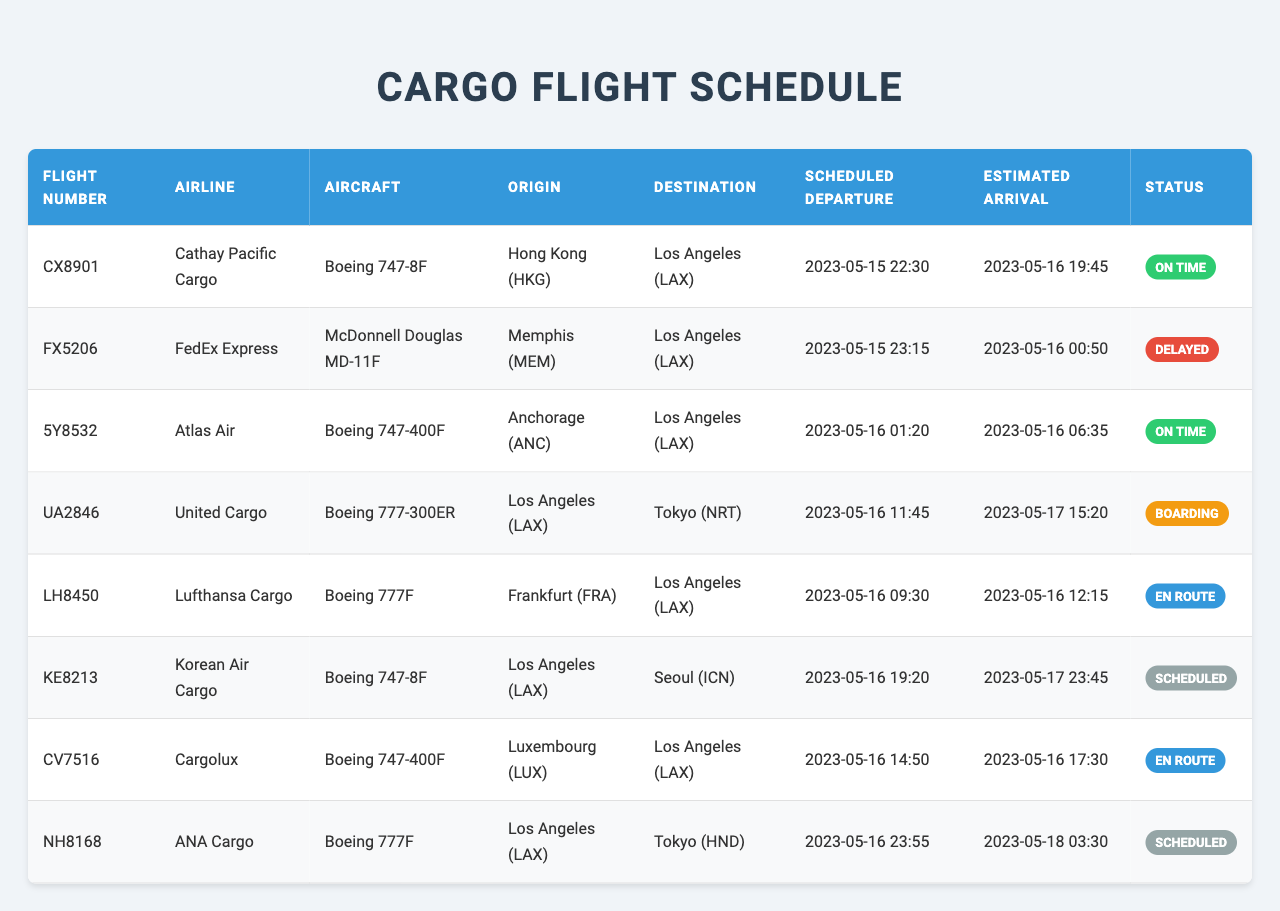What is the flight number of the FedEx Express cargo flight? The table lists the FedEx Express cargo flight under the Airline column, and its corresponding Flight Number is shown in the same row. The Flight Number for FedEx Express is FX5206.
Answer: FX5206 Which cargo flight is currently boarding? Looking at the Status column in the table, the flight with the status "Boarding" is identified. The corresponding flight number for United Cargo's flight is UA2846.
Answer: UA2846 Which aircraft is used by Cathay Pacific Cargo? By locating the row for Cathay Pacific Cargo in the table, we can find the Aircraft type listed in the same row. Cathay Pacific Cargo operates a Boeing 747-8F.
Answer: Boeing 747-8F How many cargo flights are en route to Los Angeles? We need to count the number of flights listed in the table with the status "En Route". There are two flights with this status: LH8450 and CV7516. Thus, the count is 2.
Answer: 2 What time is the estimated arrival of flight 5Y8532? To find the estimated arrival for flight 5Y8532, we check the Estimated Arrival column corresponding to its entry in the table. The estimated arrival time is 2023-05-16 06:35.
Answer: 2023-05-16 06:35 Is there a flight from Los Angeles to Tokyo? We need to check the Origin and Destination columns to see if there is a flight departing from Los Angeles with a destination of Tokyo. The flight UA2846 travels from Los Angeles (LAX) to Tokyo (NRT), confirming the existence of such a flight.
Answer: Yes What is the departure status of the flight with the earliest scheduled departure? We first need to identify the flight with the earliest Scheduled Departure time in the table, which is CX8901 at 2023-05-15 22:30, and then look for its status. The status is "On Time".
Answer: On Time How many flights are scheduled after 2023-05-16 12:00? We inspect the Scheduled Departure column and count the flights that have a scheduled departure time after 12:00 on 2023-05-16. The flights that meet this criterion are KE8213, NH8168. So, there are 2 such flights.
Answer: 2 What is the difference in estimated arrival times between FX5206 and 5Y8532? To find the difference, we note the estimated arrival times: FX5206 is 2023-05-16 00:50 and 5Y8532 is 2023-05-16 06:35. Calculating the difference gives us 5 hours and 45 minutes, or 345 minutes total.
Answer: 5 hours 45 minutes What is the latest scheduled departure time listed in the table? We need to scan through the Scheduled Departure column to identify the latest time. The latest scheduled departure is for flight NH8168 at 23:55 on 2023-05-16.
Answer: 2023-05-16 23:55 Is any flight from Frankfurt expected to arrive on the same day? Checking the table for a flight from Frankfurt (FRA), we find LH8450 with an estimated arrival of 2023-05-16 12:15. Since this occurs on the same day, the answer is yes.
Answer: Yes 